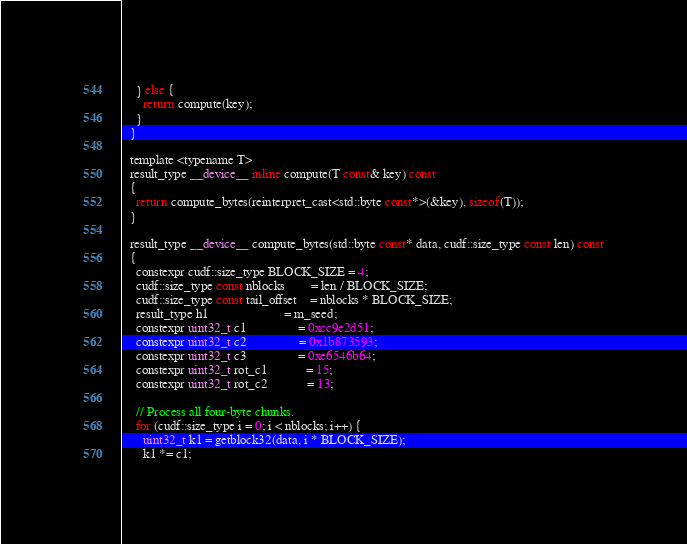<code> <loc_0><loc_0><loc_500><loc_500><_Cuda_>    } else {
      return compute(key);
    }
  }

  template <typename T>
  result_type __device__ inline compute(T const& key) const
  {
    return compute_bytes(reinterpret_cast<std::byte const*>(&key), sizeof(T));
  }

  result_type __device__ compute_bytes(std::byte const* data, cudf::size_type const len) const
  {
    constexpr cudf::size_type BLOCK_SIZE = 4;
    cudf::size_type const nblocks        = len / BLOCK_SIZE;
    cudf::size_type const tail_offset    = nblocks * BLOCK_SIZE;
    result_type h1                       = m_seed;
    constexpr uint32_t c1                = 0xcc9e2d51;
    constexpr uint32_t c2                = 0x1b873593;
    constexpr uint32_t c3                = 0xe6546b64;
    constexpr uint32_t rot_c1            = 15;
    constexpr uint32_t rot_c2            = 13;

    // Process all four-byte chunks.
    for (cudf::size_type i = 0; i < nblocks; i++) {
      uint32_t k1 = getblock32(data, i * BLOCK_SIZE);
      k1 *= c1;</code> 